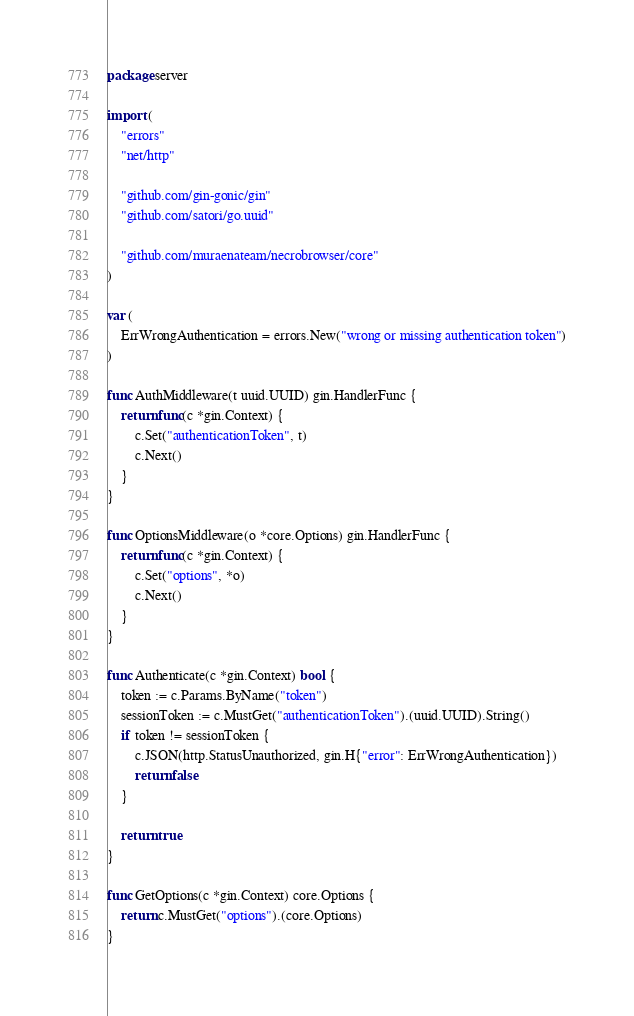Convert code to text. <code><loc_0><loc_0><loc_500><loc_500><_Go_>package server

import (
	"errors"
	"net/http"

	"github.com/gin-gonic/gin"
	"github.com/satori/go.uuid"

	"github.com/muraenateam/necrobrowser/core"
)

var (
	ErrWrongAuthentication = errors.New("wrong or missing authentication token")
)

func AuthMiddleware(t uuid.UUID) gin.HandlerFunc {
	return func(c *gin.Context) {
		c.Set("authenticationToken", t)
		c.Next()
	}
}

func OptionsMiddleware(o *core.Options) gin.HandlerFunc {
	return func(c *gin.Context) {
		c.Set("options", *o)
		c.Next()
	}
}

func Authenticate(c *gin.Context) bool {
	token := c.Params.ByName("token")
	sessionToken := c.MustGet("authenticationToken").(uuid.UUID).String()
	if token != sessionToken {
		c.JSON(http.StatusUnauthorized, gin.H{"error": ErrWrongAuthentication})
		return false
	}

	return true
}

func GetOptions(c *gin.Context) core.Options {
	return c.MustGet("options").(core.Options)
}
</code> 